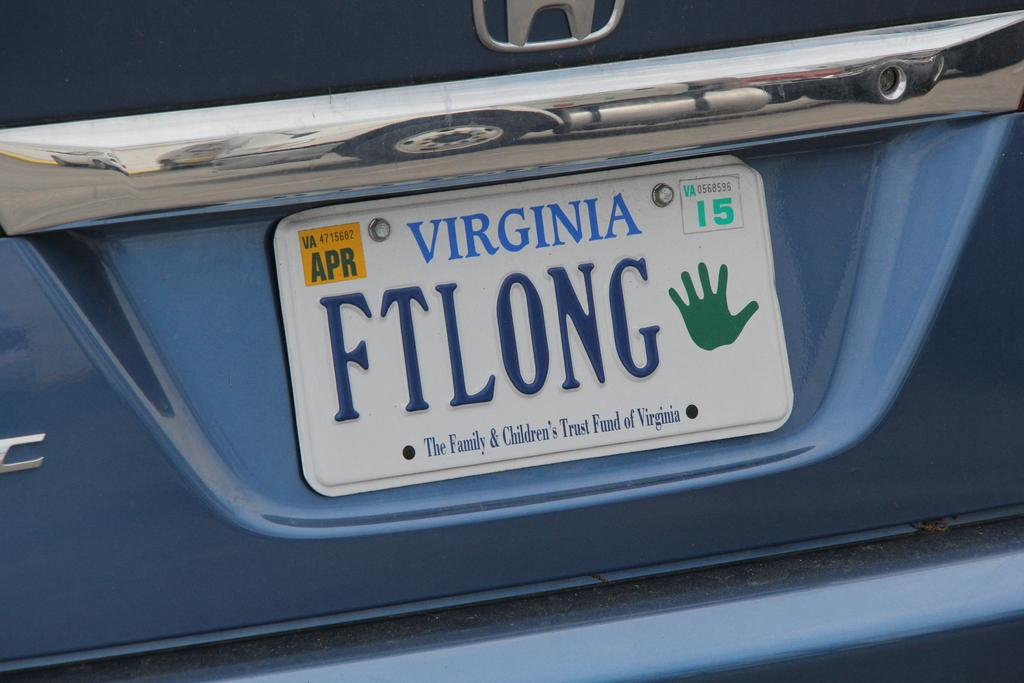Provide a one-sentence caption for the provided image. The license plate indicates support of the Family & Children's Trust Fund of Virginia. 